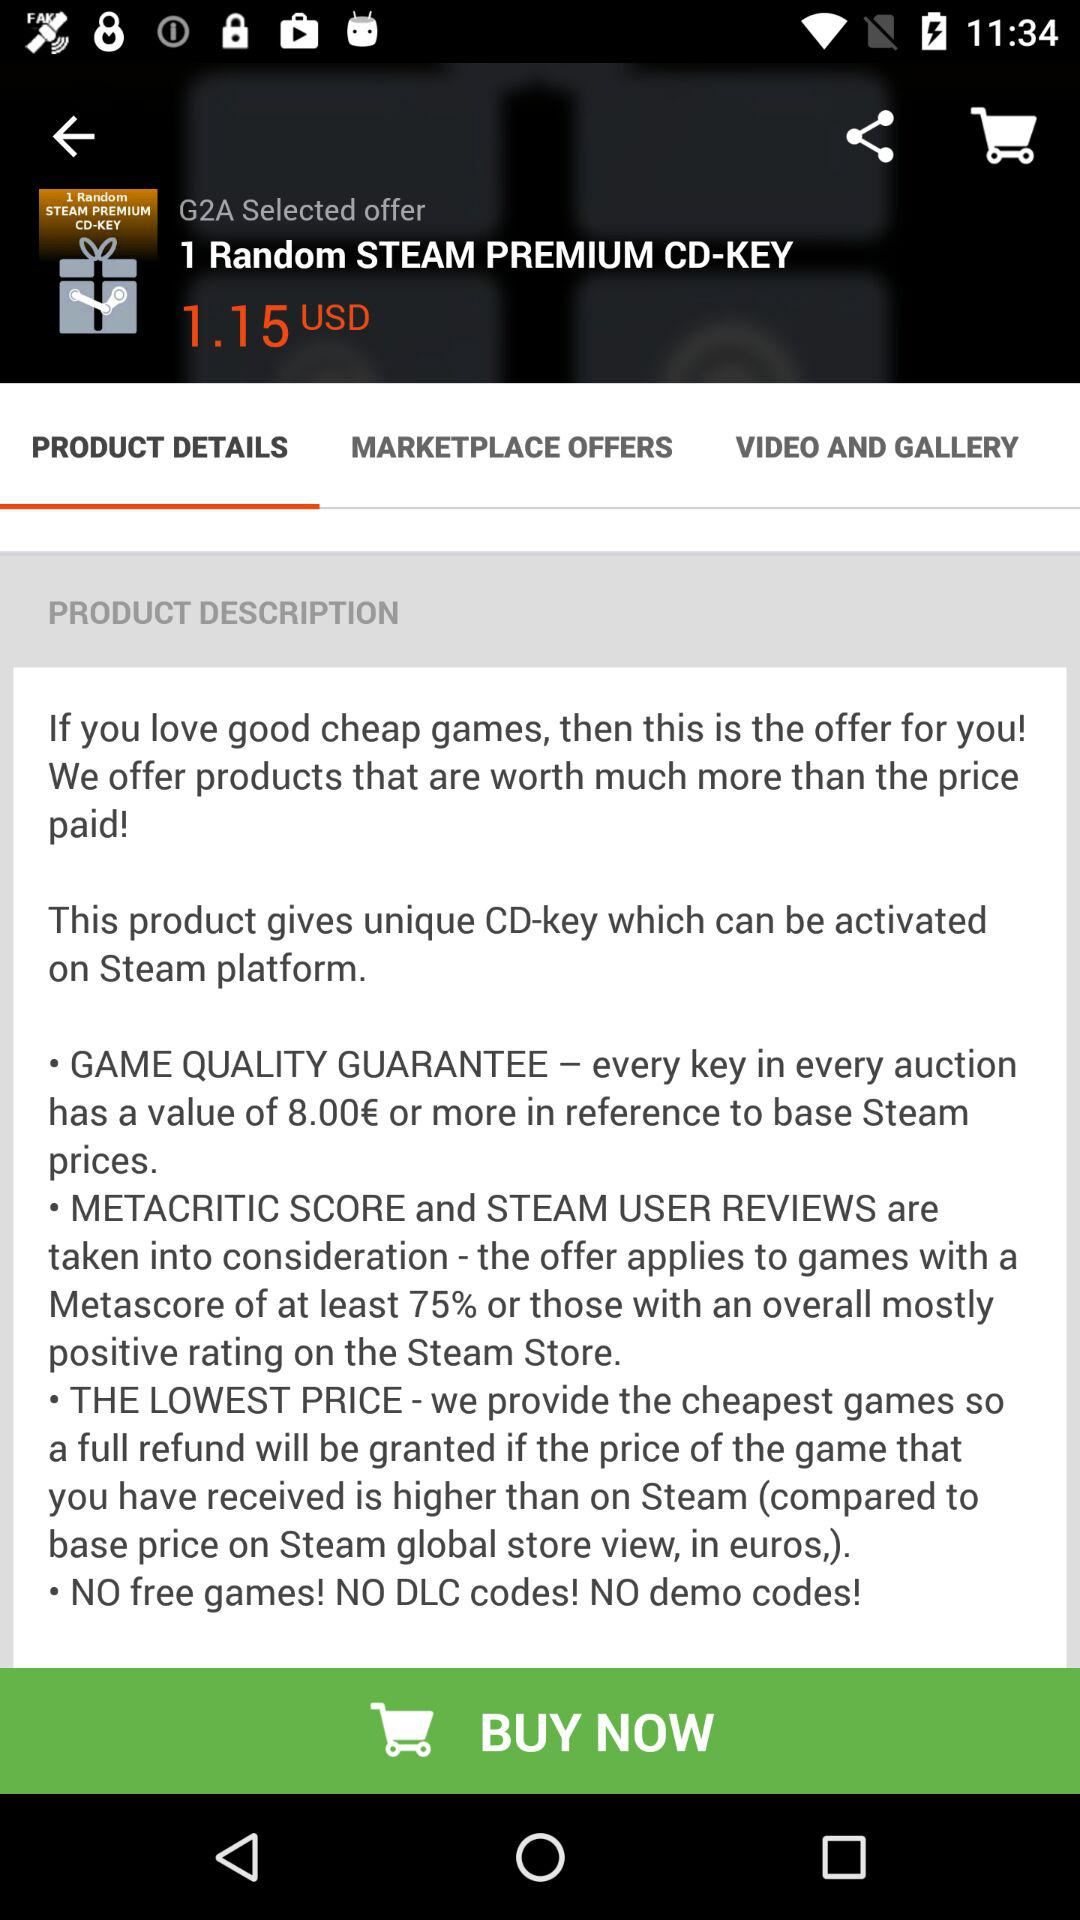What tab is selected? The selected tab is "PRODUCT DETAILS". 